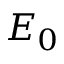Convert formula to latex. <formula><loc_0><loc_0><loc_500><loc_500>E _ { 0 }</formula> 